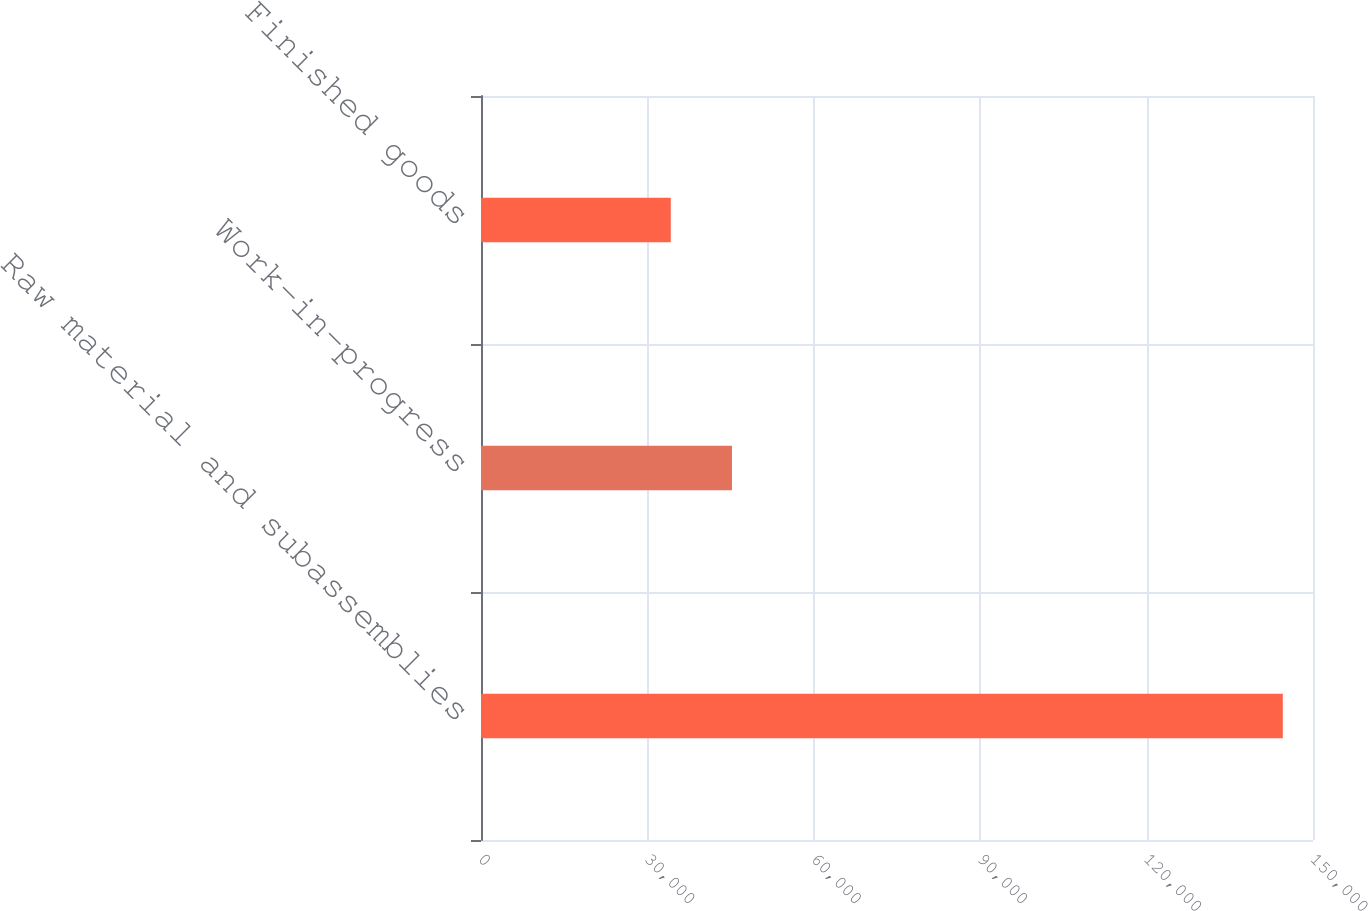Convert chart to OTSL. <chart><loc_0><loc_0><loc_500><loc_500><bar_chart><fcel>Raw material and subassemblies<fcel>Work-in-progress<fcel>Finished goods<nl><fcel>144555<fcel>45247.2<fcel>34213<nl></chart> 